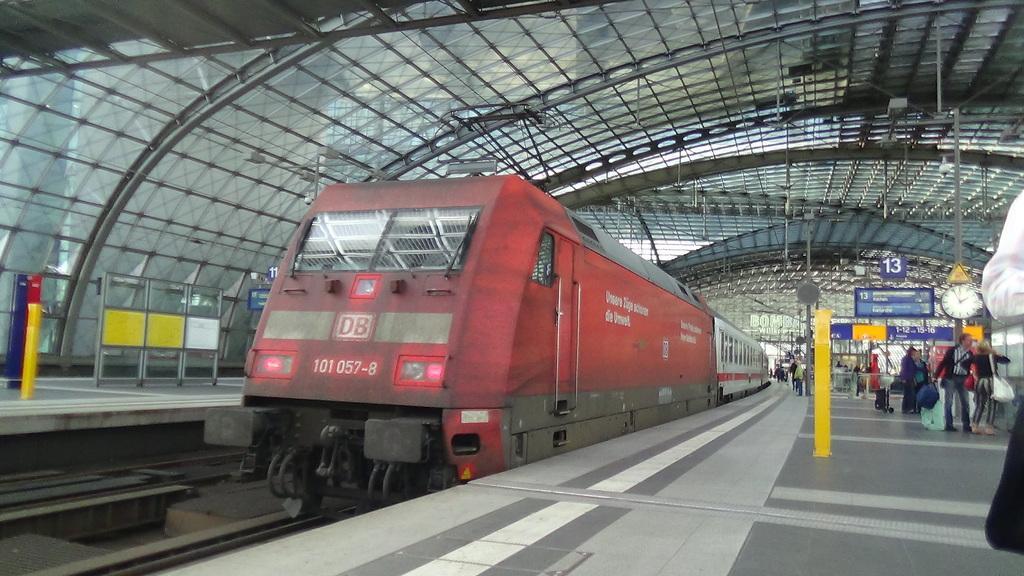Could you give a brief overview of what you see in this image? In the foreground, I can see poles, boards, clock, train on a track and a crowd on the platform. In the background, I can see metal objects, rooftop and so on. This image taken, maybe on the platform. 